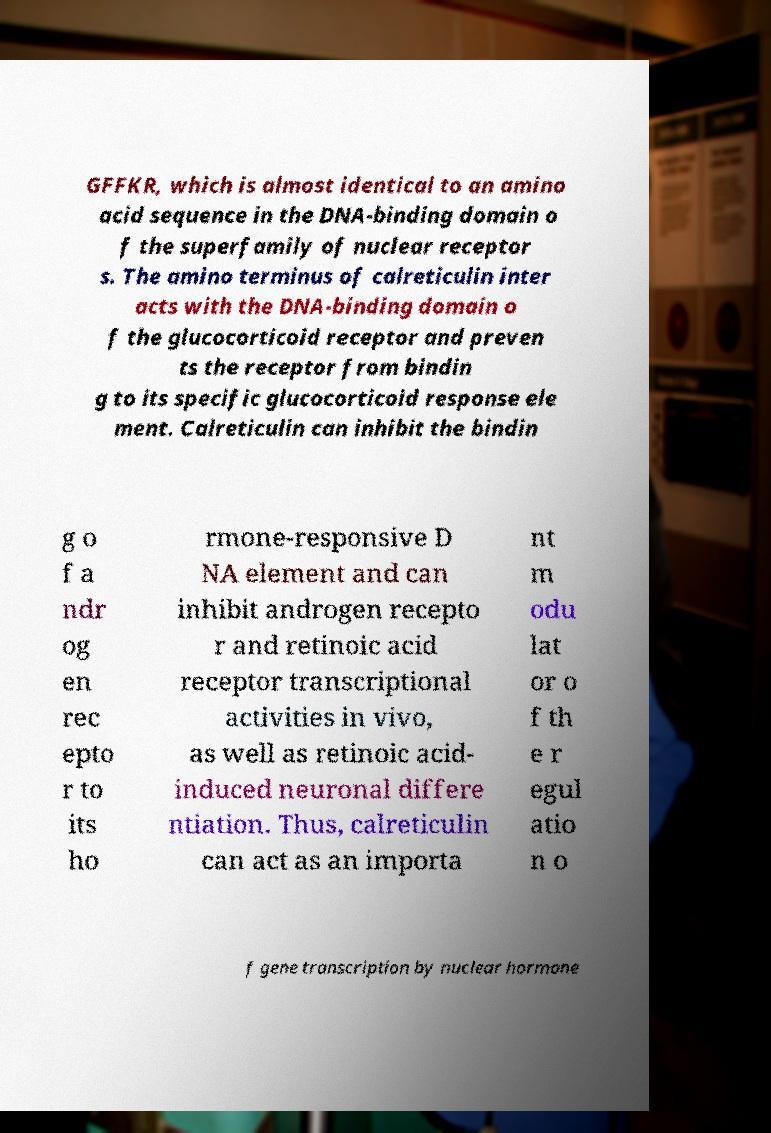There's text embedded in this image that I need extracted. Can you transcribe it verbatim? GFFKR, which is almost identical to an amino acid sequence in the DNA-binding domain o f the superfamily of nuclear receptor s. The amino terminus of calreticulin inter acts with the DNA-binding domain o f the glucocorticoid receptor and preven ts the receptor from bindin g to its specific glucocorticoid response ele ment. Calreticulin can inhibit the bindin g o f a ndr og en rec epto r to its ho rmone-responsive D NA element and can inhibit androgen recepto r and retinoic acid receptor transcriptional activities in vivo, as well as retinoic acid- induced neuronal differe ntiation. Thus, calreticulin can act as an importa nt m odu lat or o f th e r egul atio n o f gene transcription by nuclear hormone 